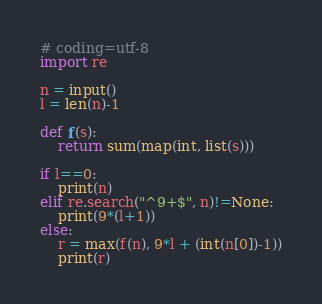<code> <loc_0><loc_0><loc_500><loc_500><_Python_># coding=utf-8
import re

n = input()
l = len(n)-1

def f(s):
    return sum(map(int, list(s)))

if l==0:
    print(n)
elif re.search("^9+$", n)!=None:
    print(9*(l+1))
else:
    r = max(f(n), 9*l + (int(n[0])-1))
    print(r)
</code> 